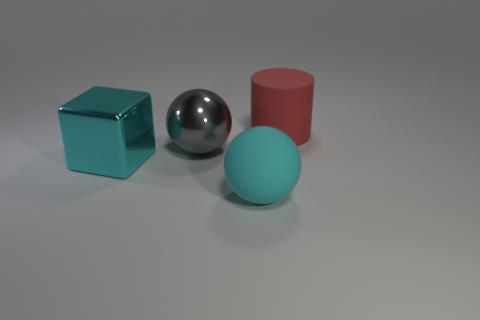How many things are the same color as the large rubber ball?
Offer a very short reply. 1. What material is the ball that is the same color as the large block?
Your answer should be very brief. Rubber. How many objects are either yellow metal cylinders or objects behind the big cyan block?
Keep it short and to the point. 2. Is there a large blue object that has the same material as the gray thing?
Your answer should be very brief. No. What material is the red cylinder that is the same size as the gray ball?
Keep it short and to the point. Rubber. What material is the big cyan thing on the left side of the sphere that is in front of the big cyan metallic cube made of?
Provide a succinct answer. Metal. Is the shape of the thing that is behind the large gray thing the same as  the large gray shiny thing?
Offer a terse response. No. There is a cube that is made of the same material as the large gray sphere; what is its color?
Your response must be concise. Cyan. There is a big ball that is to the left of the big matte sphere; what material is it?
Make the answer very short. Metal. There is a gray object; is it the same shape as the cyan object right of the big gray thing?
Your answer should be very brief. Yes. 